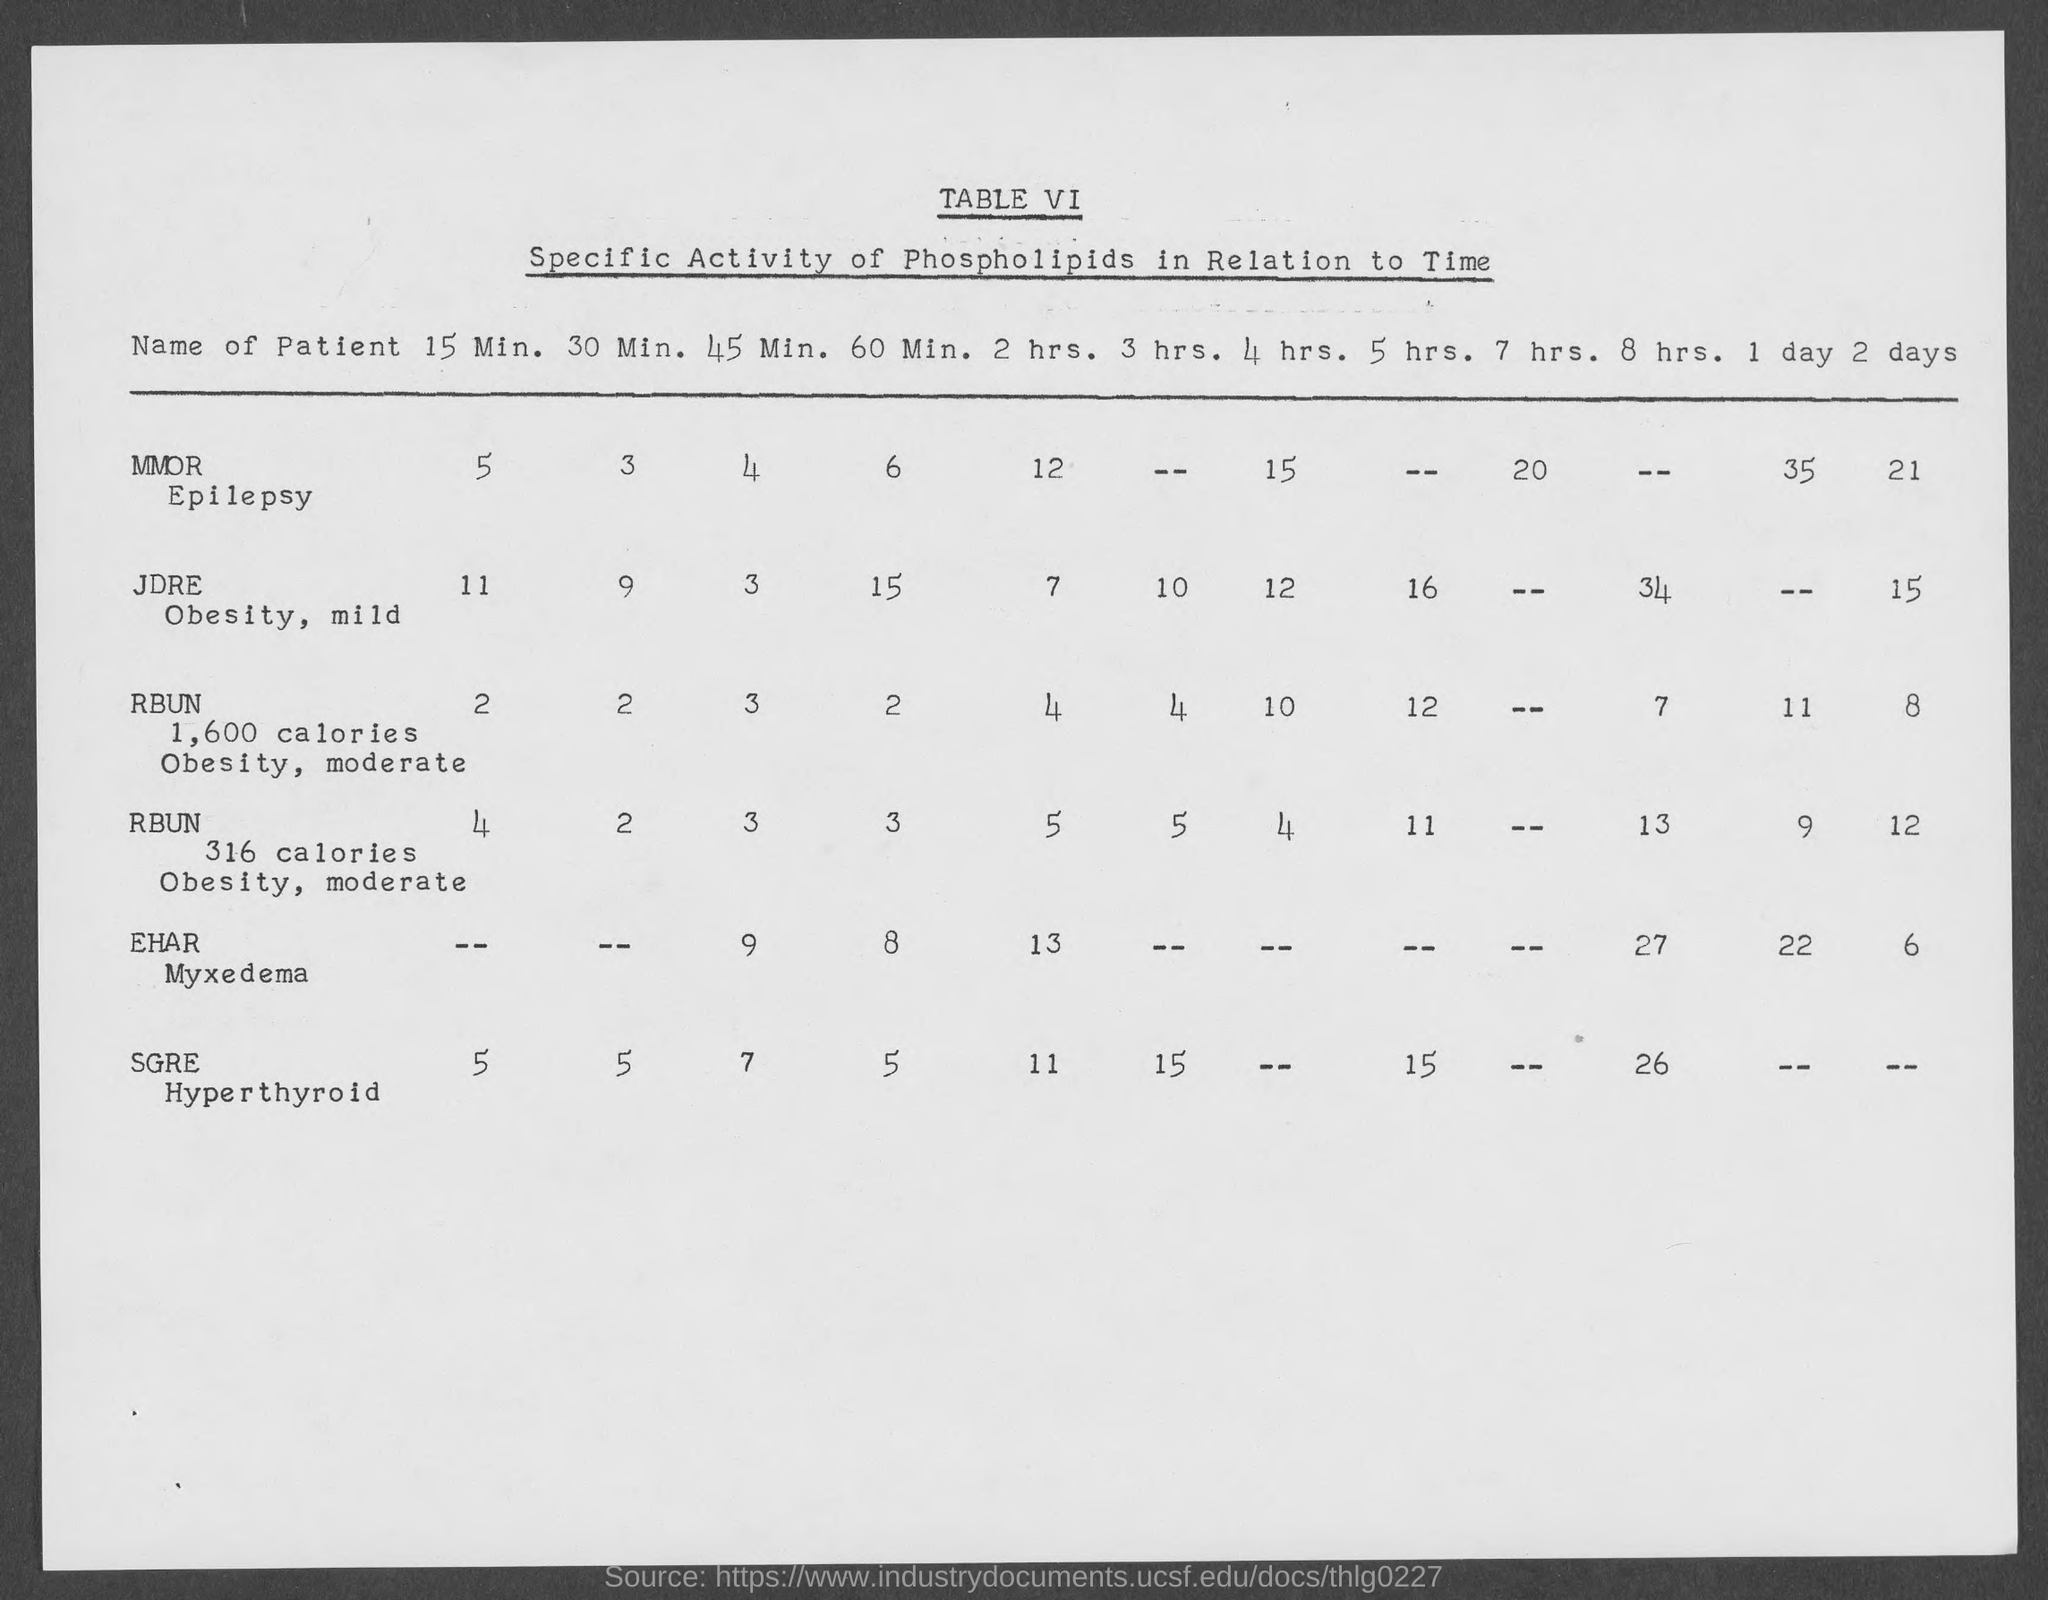What is the table no.?
Your response must be concise. VI. 